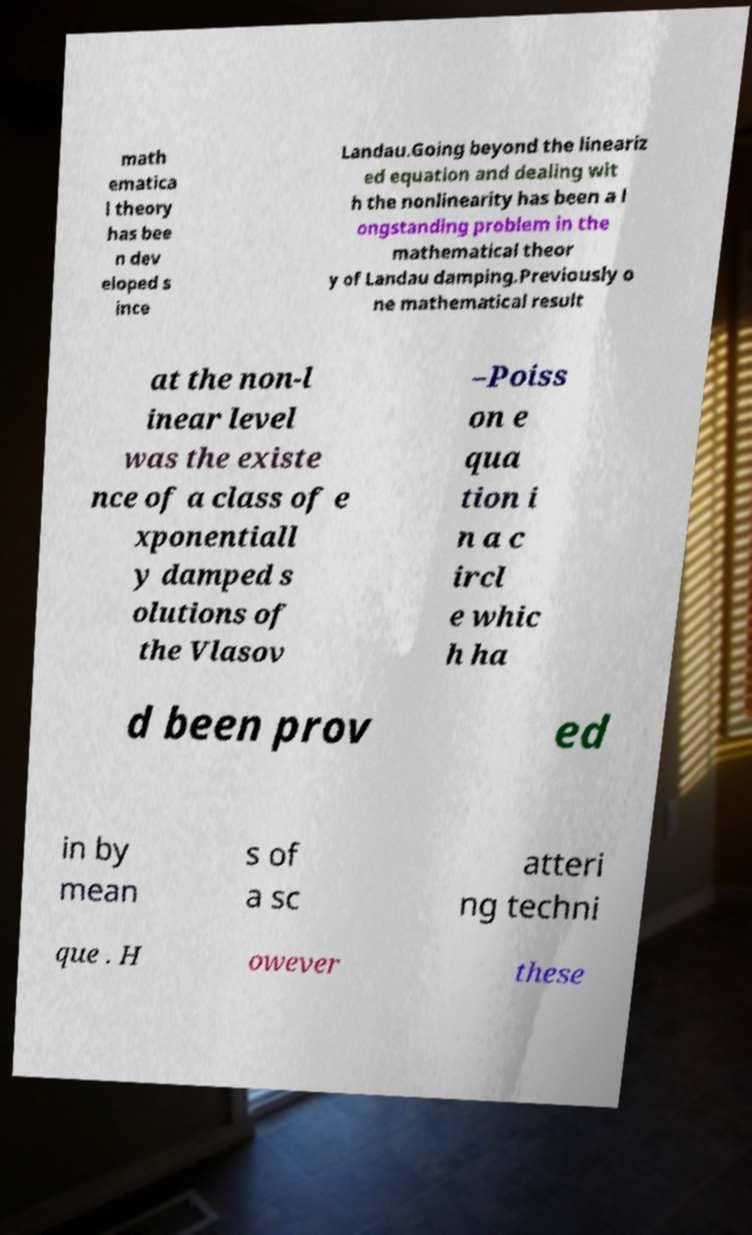Could you assist in decoding the text presented in this image and type it out clearly? math ematica l theory has bee n dev eloped s ince Landau.Going beyond the lineariz ed equation and dealing wit h the nonlinearity has been a l ongstanding problem in the mathematical theor y of Landau damping.Previously o ne mathematical result at the non-l inear level was the existe nce of a class of e xponentiall y damped s olutions of the Vlasov –Poiss on e qua tion i n a c ircl e whic h ha d been prov ed in by mean s of a sc atteri ng techni que . H owever these 